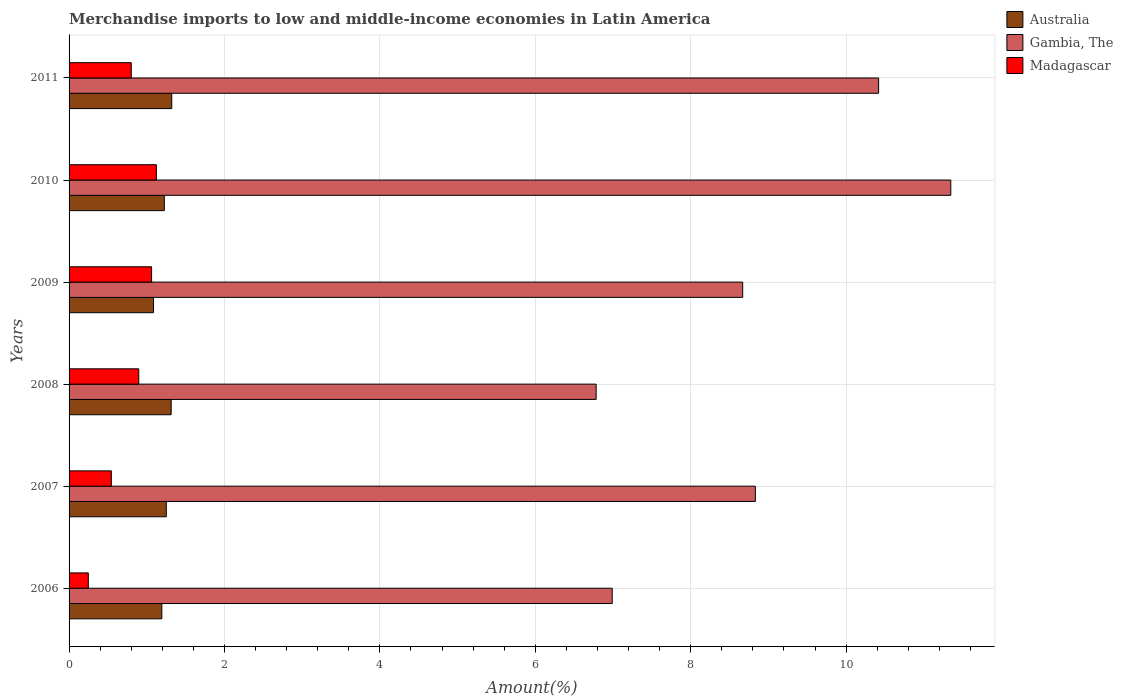How many different coloured bars are there?
Offer a terse response. 3. How many groups of bars are there?
Offer a very short reply. 6. Are the number of bars on each tick of the Y-axis equal?
Make the answer very short. Yes. How many bars are there on the 1st tick from the bottom?
Your answer should be very brief. 3. What is the label of the 5th group of bars from the top?
Provide a succinct answer. 2007. In how many cases, is the number of bars for a given year not equal to the number of legend labels?
Make the answer very short. 0. What is the percentage of amount earned from merchandise imports in Australia in 2007?
Provide a succinct answer. 1.25. Across all years, what is the maximum percentage of amount earned from merchandise imports in Madagascar?
Give a very brief answer. 1.12. Across all years, what is the minimum percentage of amount earned from merchandise imports in Gambia, The?
Make the answer very short. 6.78. What is the total percentage of amount earned from merchandise imports in Gambia, The in the graph?
Ensure brevity in your answer.  53.04. What is the difference between the percentage of amount earned from merchandise imports in Australia in 2007 and that in 2008?
Provide a succinct answer. -0.06. What is the difference between the percentage of amount earned from merchandise imports in Madagascar in 2006 and the percentage of amount earned from merchandise imports in Australia in 2008?
Your answer should be compact. -1.07. What is the average percentage of amount earned from merchandise imports in Gambia, The per year?
Make the answer very short. 8.84. In the year 2010, what is the difference between the percentage of amount earned from merchandise imports in Australia and percentage of amount earned from merchandise imports in Madagascar?
Offer a terse response. 0.1. In how many years, is the percentage of amount earned from merchandise imports in Australia greater than 5.2 %?
Your answer should be compact. 0. What is the ratio of the percentage of amount earned from merchandise imports in Madagascar in 2007 to that in 2008?
Ensure brevity in your answer.  0.61. Is the difference between the percentage of amount earned from merchandise imports in Australia in 2008 and 2010 greater than the difference between the percentage of amount earned from merchandise imports in Madagascar in 2008 and 2010?
Ensure brevity in your answer.  Yes. What is the difference between the highest and the second highest percentage of amount earned from merchandise imports in Madagascar?
Your response must be concise. 0.06. What is the difference between the highest and the lowest percentage of amount earned from merchandise imports in Madagascar?
Offer a very short reply. 0.88. In how many years, is the percentage of amount earned from merchandise imports in Madagascar greater than the average percentage of amount earned from merchandise imports in Madagascar taken over all years?
Your answer should be very brief. 4. What does the 2nd bar from the top in 2009 represents?
Your response must be concise. Gambia, The. What does the 3rd bar from the bottom in 2011 represents?
Make the answer very short. Madagascar. How many bars are there?
Offer a terse response. 18. Are all the bars in the graph horizontal?
Ensure brevity in your answer.  Yes. How many years are there in the graph?
Ensure brevity in your answer.  6. How many legend labels are there?
Make the answer very short. 3. What is the title of the graph?
Make the answer very short. Merchandise imports to low and middle-income economies in Latin America. Does "Bangladesh" appear as one of the legend labels in the graph?
Give a very brief answer. No. What is the label or title of the X-axis?
Give a very brief answer. Amount(%). What is the Amount(%) in Australia in 2006?
Offer a very short reply. 1.19. What is the Amount(%) in Gambia, The in 2006?
Give a very brief answer. 6.99. What is the Amount(%) in Madagascar in 2006?
Provide a succinct answer. 0.25. What is the Amount(%) in Australia in 2007?
Provide a succinct answer. 1.25. What is the Amount(%) of Gambia, The in 2007?
Offer a terse response. 8.83. What is the Amount(%) in Madagascar in 2007?
Keep it short and to the point. 0.54. What is the Amount(%) in Australia in 2008?
Your answer should be compact. 1.31. What is the Amount(%) in Gambia, The in 2008?
Your response must be concise. 6.78. What is the Amount(%) of Madagascar in 2008?
Offer a very short reply. 0.9. What is the Amount(%) of Australia in 2009?
Ensure brevity in your answer.  1.09. What is the Amount(%) in Gambia, The in 2009?
Make the answer very short. 8.67. What is the Amount(%) of Madagascar in 2009?
Offer a very short reply. 1.06. What is the Amount(%) of Australia in 2010?
Offer a very short reply. 1.23. What is the Amount(%) in Gambia, The in 2010?
Make the answer very short. 11.35. What is the Amount(%) in Madagascar in 2010?
Your response must be concise. 1.12. What is the Amount(%) in Australia in 2011?
Provide a short and direct response. 1.32. What is the Amount(%) of Gambia, The in 2011?
Your answer should be compact. 10.42. What is the Amount(%) in Madagascar in 2011?
Provide a short and direct response. 0.8. Across all years, what is the maximum Amount(%) of Australia?
Offer a terse response. 1.32. Across all years, what is the maximum Amount(%) of Gambia, The?
Offer a very short reply. 11.35. Across all years, what is the maximum Amount(%) in Madagascar?
Give a very brief answer. 1.12. Across all years, what is the minimum Amount(%) of Australia?
Provide a short and direct response. 1.09. Across all years, what is the minimum Amount(%) in Gambia, The?
Provide a succinct answer. 6.78. Across all years, what is the minimum Amount(%) of Madagascar?
Your answer should be compact. 0.25. What is the total Amount(%) of Australia in the graph?
Your answer should be very brief. 7.39. What is the total Amount(%) of Gambia, The in the graph?
Make the answer very short. 53.04. What is the total Amount(%) in Madagascar in the graph?
Your answer should be compact. 4.67. What is the difference between the Amount(%) in Australia in 2006 and that in 2007?
Your answer should be very brief. -0.06. What is the difference between the Amount(%) in Gambia, The in 2006 and that in 2007?
Your answer should be very brief. -1.84. What is the difference between the Amount(%) in Madagascar in 2006 and that in 2007?
Give a very brief answer. -0.3. What is the difference between the Amount(%) of Australia in 2006 and that in 2008?
Make the answer very short. -0.12. What is the difference between the Amount(%) of Gambia, The in 2006 and that in 2008?
Provide a short and direct response. 0.21. What is the difference between the Amount(%) of Madagascar in 2006 and that in 2008?
Offer a terse response. -0.65. What is the difference between the Amount(%) in Australia in 2006 and that in 2009?
Provide a succinct answer. 0.11. What is the difference between the Amount(%) of Gambia, The in 2006 and that in 2009?
Provide a succinct answer. -1.68. What is the difference between the Amount(%) of Madagascar in 2006 and that in 2009?
Your answer should be very brief. -0.81. What is the difference between the Amount(%) in Australia in 2006 and that in 2010?
Provide a succinct answer. -0.03. What is the difference between the Amount(%) of Gambia, The in 2006 and that in 2010?
Give a very brief answer. -4.36. What is the difference between the Amount(%) of Madagascar in 2006 and that in 2010?
Your answer should be very brief. -0.88. What is the difference between the Amount(%) in Australia in 2006 and that in 2011?
Ensure brevity in your answer.  -0.13. What is the difference between the Amount(%) in Gambia, The in 2006 and that in 2011?
Your response must be concise. -3.43. What is the difference between the Amount(%) in Madagascar in 2006 and that in 2011?
Offer a very short reply. -0.55. What is the difference between the Amount(%) of Australia in 2007 and that in 2008?
Your answer should be very brief. -0.06. What is the difference between the Amount(%) of Gambia, The in 2007 and that in 2008?
Provide a succinct answer. 2.05. What is the difference between the Amount(%) in Madagascar in 2007 and that in 2008?
Ensure brevity in your answer.  -0.35. What is the difference between the Amount(%) of Australia in 2007 and that in 2009?
Your response must be concise. 0.16. What is the difference between the Amount(%) of Gambia, The in 2007 and that in 2009?
Make the answer very short. 0.16. What is the difference between the Amount(%) of Madagascar in 2007 and that in 2009?
Offer a very short reply. -0.52. What is the difference between the Amount(%) of Australia in 2007 and that in 2010?
Make the answer very short. 0.03. What is the difference between the Amount(%) in Gambia, The in 2007 and that in 2010?
Offer a very short reply. -2.52. What is the difference between the Amount(%) in Madagascar in 2007 and that in 2010?
Keep it short and to the point. -0.58. What is the difference between the Amount(%) in Australia in 2007 and that in 2011?
Keep it short and to the point. -0.07. What is the difference between the Amount(%) of Gambia, The in 2007 and that in 2011?
Provide a succinct answer. -1.59. What is the difference between the Amount(%) in Madagascar in 2007 and that in 2011?
Your answer should be very brief. -0.26. What is the difference between the Amount(%) in Australia in 2008 and that in 2009?
Offer a very short reply. 0.23. What is the difference between the Amount(%) of Gambia, The in 2008 and that in 2009?
Offer a terse response. -1.89. What is the difference between the Amount(%) of Madagascar in 2008 and that in 2009?
Your answer should be very brief. -0.17. What is the difference between the Amount(%) of Australia in 2008 and that in 2010?
Keep it short and to the point. 0.09. What is the difference between the Amount(%) in Gambia, The in 2008 and that in 2010?
Offer a very short reply. -4.56. What is the difference between the Amount(%) in Madagascar in 2008 and that in 2010?
Your response must be concise. -0.23. What is the difference between the Amount(%) of Australia in 2008 and that in 2011?
Ensure brevity in your answer.  -0.01. What is the difference between the Amount(%) in Gambia, The in 2008 and that in 2011?
Provide a succinct answer. -3.63. What is the difference between the Amount(%) of Madagascar in 2008 and that in 2011?
Ensure brevity in your answer.  0.1. What is the difference between the Amount(%) of Australia in 2009 and that in 2010?
Ensure brevity in your answer.  -0.14. What is the difference between the Amount(%) of Gambia, The in 2009 and that in 2010?
Your response must be concise. -2.68. What is the difference between the Amount(%) of Madagascar in 2009 and that in 2010?
Your answer should be very brief. -0.06. What is the difference between the Amount(%) of Australia in 2009 and that in 2011?
Provide a short and direct response. -0.23. What is the difference between the Amount(%) of Gambia, The in 2009 and that in 2011?
Keep it short and to the point. -1.75. What is the difference between the Amount(%) in Madagascar in 2009 and that in 2011?
Offer a terse response. 0.26. What is the difference between the Amount(%) of Australia in 2010 and that in 2011?
Ensure brevity in your answer.  -0.1. What is the difference between the Amount(%) of Gambia, The in 2010 and that in 2011?
Make the answer very short. 0.93. What is the difference between the Amount(%) of Madagascar in 2010 and that in 2011?
Keep it short and to the point. 0.32. What is the difference between the Amount(%) of Australia in 2006 and the Amount(%) of Gambia, The in 2007?
Provide a short and direct response. -7.64. What is the difference between the Amount(%) in Australia in 2006 and the Amount(%) in Madagascar in 2007?
Offer a very short reply. 0.65. What is the difference between the Amount(%) in Gambia, The in 2006 and the Amount(%) in Madagascar in 2007?
Provide a short and direct response. 6.45. What is the difference between the Amount(%) in Australia in 2006 and the Amount(%) in Gambia, The in 2008?
Keep it short and to the point. -5.59. What is the difference between the Amount(%) of Australia in 2006 and the Amount(%) of Madagascar in 2008?
Provide a short and direct response. 0.3. What is the difference between the Amount(%) in Gambia, The in 2006 and the Amount(%) in Madagascar in 2008?
Provide a short and direct response. 6.09. What is the difference between the Amount(%) in Australia in 2006 and the Amount(%) in Gambia, The in 2009?
Offer a very short reply. -7.47. What is the difference between the Amount(%) in Australia in 2006 and the Amount(%) in Madagascar in 2009?
Offer a terse response. 0.13. What is the difference between the Amount(%) of Gambia, The in 2006 and the Amount(%) of Madagascar in 2009?
Your answer should be compact. 5.93. What is the difference between the Amount(%) in Australia in 2006 and the Amount(%) in Gambia, The in 2010?
Provide a short and direct response. -10.15. What is the difference between the Amount(%) of Australia in 2006 and the Amount(%) of Madagascar in 2010?
Offer a very short reply. 0.07. What is the difference between the Amount(%) in Gambia, The in 2006 and the Amount(%) in Madagascar in 2010?
Offer a terse response. 5.87. What is the difference between the Amount(%) of Australia in 2006 and the Amount(%) of Gambia, The in 2011?
Ensure brevity in your answer.  -9.22. What is the difference between the Amount(%) in Australia in 2006 and the Amount(%) in Madagascar in 2011?
Offer a very short reply. 0.39. What is the difference between the Amount(%) in Gambia, The in 2006 and the Amount(%) in Madagascar in 2011?
Your response must be concise. 6.19. What is the difference between the Amount(%) in Australia in 2007 and the Amount(%) in Gambia, The in 2008?
Make the answer very short. -5.53. What is the difference between the Amount(%) in Australia in 2007 and the Amount(%) in Madagascar in 2008?
Give a very brief answer. 0.35. What is the difference between the Amount(%) in Gambia, The in 2007 and the Amount(%) in Madagascar in 2008?
Ensure brevity in your answer.  7.93. What is the difference between the Amount(%) in Australia in 2007 and the Amount(%) in Gambia, The in 2009?
Ensure brevity in your answer.  -7.42. What is the difference between the Amount(%) in Australia in 2007 and the Amount(%) in Madagascar in 2009?
Make the answer very short. 0.19. What is the difference between the Amount(%) in Gambia, The in 2007 and the Amount(%) in Madagascar in 2009?
Provide a succinct answer. 7.77. What is the difference between the Amount(%) in Australia in 2007 and the Amount(%) in Gambia, The in 2010?
Offer a terse response. -10.1. What is the difference between the Amount(%) of Australia in 2007 and the Amount(%) of Madagascar in 2010?
Your response must be concise. 0.13. What is the difference between the Amount(%) in Gambia, The in 2007 and the Amount(%) in Madagascar in 2010?
Your response must be concise. 7.71. What is the difference between the Amount(%) in Australia in 2007 and the Amount(%) in Gambia, The in 2011?
Keep it short and to the point. -9.17. What is the difference between the Amount(%) of Australia in 2007 and the Amount(%) of Madagascar in 2011?
Provide a short and direct response. 0.45. What is the difference between the Amount(%) in Gambia, The in 2007 and the Amount(%) in Madagascar in 2011?
Provide a short and direct response. 8.03. What is the difference between the Amount(%) of Australia in 2008 and the Amount(%) of Gambia, The in 2009?
Ensure brevity in your answer.  -7.36. What is the difference between the Amount(%) in Australia in 2008 and the Amount(%) in Madagascar in 2009?
Provide a succinct answer. 0.25. What is the difference between the Amount(%) of Gambia, The in 2008 and the Amount(%) of Madagascar in 2009?
Keep it short and to the point. 5.72. What is the difference between the Amount(%) of Australia in 2008 and the Amount(%) of Gambia, The in 2010?
Your answer should be very brief. -10.03. What is the difference between the Amount(%) of Australia in 2008 and the Amount(%) of Madagascar in 2010?
Make the answer very short. 0.19. What is the difference between the Amount(%) in Gambia, The in 2008 and the Amount(%) in Madagascar in 2010?
Keep it short and to the point. 5.66. What is the difference between the Amount(%) of Australia in 2008 and the Amount(%) of Gambia, The in 2011?
Your answer should be compact. -9.1. What is the difference between the Amount(%) of Australia in 2008 and the Amount(%) of Madagascar in 2011?
Keep it short and to the point. 0.51. What is the difference between the Amount(%) in Gambia, The in 2008 and the Amount(%) in Madagascar in 2011?
Keep it short and to the point. 5.98. What is the difference between the Amount(%) of Australia in 2009 and the Amount(%) of Gambia, The in 2010?
Give a very brief answer. -10.26. What is the difference between the Amount(%) in Australia in 2009 and the Amount(%) in Madagascar in 2010?
Offer a very short reply. -0.04. What is the difference between the Amount(%) in Gambia, The in 2009 and the Amount(%) in Madagascar in 2010?
Provide a succinct answer. 7.54. What is the difference between the Amount(%) in Australia in 2009 and the Amount(%) in Gambia, The in 2011?
Ensure brevity in your answer.  -9.33. What is the difference between the Amount(%) of Australia in 2009 and the Amount(%) of Madagascar in 2011?
Give a very brief answer. 0.29. What is the difference between the Amount(%) of Gambia, The in 2009 and the Amount(%) of Madagascar in 2011?
Provide a succinct answer. 7.87. What is the difference between the Amount(%) of Australia in 2010 and the Amount(%) of Gambia, The in 2011?
Offer a terse response. -9.19. What is the difference between the Amount(%) of Australia in 2010 and the Amount(%) of Madagascar in 2011?
Give a very brief answer. 0.43. What is the difference between the Amount(%) in Gambia, The in 2010 and the Amount(%) in Madagascar in 2011?
Make the answer very short. 10.55. What is the average Amount(%) in Australia per year?
Keep it short and to the point. 1.23. What is the average Amount(%) of Gambia, The per year?
Offer a terse response. 8.84. What is the average Amount(%) of Madagascar per year?
Your answer should be very brief. 0.78. In the year 2006, what is the difference between the Amount(%) in Australia and Amount(%) in Gambia, The?
Provide a succinct answer. -5.8. In the year 2006, what is the difference between the Amount(%) of Australia and Amount(%) of Madagascar?
Offer a very short reply. 0.95. In the year 2006, what is the difference between the Amount(%) of Gambia, The and Amount(%) of Madagascar?
Keep it short and to the point. 6.74. In the year 2007, what is the difference between the Amount(%) of Australia and Amount(%) of Gambia, The?
Your answer should be very brief. -7.58. In the year 2007, what is the difference between the Amount(%) of Australia and Amount(%) of Madagascar?
Your answer should be very brief. 0.71. In the year 2007, what is the difference between the Amount(%) in Gambia, The and Amount(%) in Madagascar?
Your answer should be very brief. 8.29. In the year 2008, what is the difference between the Amount(%) in Australia and Amount(%) in Gambia, The?
Provide a succinct answer. -5.47. In the year 2008, what is the difference between the Amount(%) in Australia and Amount(%) in Madagascar?
Keep it short and to the point. 0.42. In the year 2008, what is the difference between the Amount(%) in Gambia, The and Amount(%) in Madagascar?
Keep it short and to the point. 5.89. In the year 2009, what is the difference between the Amount(%) of Australia and Amount(%) of Gambia, The?
Make the answer very short. -7.58. In the year 2009, what is the difference between the Amount(%) of Australia and Amount(%) of Madagascar?
Provide a succinct answer. 0.03. In the year 2009, what is the difference between the Amount(%) of Gambia, The and Amount(%) of Madagascar?
Your answer should be compact. 7.61. In the year 2010, what is the difference between the Amount(%) of Australia and Amount(%) of Gambia, The?
Offer a terse response. -10.12. In the year 2010, what is the difference between the Amount(%) in Australia and Amount(%) in Madagascar?
Offer a terse response. 0.1. In the year 2010, what is the difference between the Amount(%) of Gambia, The and Amount(%) of Madagascar?
Your answer should be very brief. 10.22. In the year 2011, what is the difference between the Amount(%) in Australia and Amount(%) in Gambia, The?
Give a very brief answer. -9.1. In the year 2011, what is the difference between the Amount(%) in Australia and Amount(%) in Madagascar?
Provide a succinct answer. 0.52. In the year 2011, what is the difference between the Amount(%) of Gambia, The and Amount(%) of Madagascar?
Offer a very short reply. 9.62. What is the ratio of the Amount(%) of Australia in 2006 to that in 2007?
Give a very brief answer. 0.95. What is the ratio of the Amount(%) of Gambia, The in 2006 to that in 2007?
Give a very brief answer. 0.79. What is the ratio of the Amount(%) in Madagascar in 2006 to that in 2007?
Offer a very short reply. 0.46. What is the ratio of the Amount(%) of Australia in 2006 to that in 2008?
Offer a terse response. 0.91. What is the ratio of the Amount(%) of Gambia, The in 2006 to that in 2008?
Your answer should be very brief. 1.03. What is the ratio of the Amount(%) of Madagascar in 2006 to that in 2008?
Your response must be concise. 0.28. What is the ratio of the Amount(%) in Australia in 2006 to that in 2009?
Provide a succinct answer. 1.1. What is the ratio of the Amount(%) of Gambia, The in 2006 to that in 2009?
Provide a short and direct response. 0.81. What is the ratio of the Amount(%) in Madagascar in 2006 to that in 2009?
Keep it short and to the point. 0.23. What is the ratio of the Amount(%) in Australia in 2006 to that in 2010?
Your answer should be compact. 0.97. What is the ratio of the Amount(%) of Gambia, The in 2006 to that in 2010?
Provide a short and direct response. 0.62. What is the ratio of the Amount(%) of Madagascar in 2006 to that in 2010?
Ensure brevity in your answer.  0.22. What is the ratio of the Amount(%) in Australia in 2006 to that in 2011?
Provide a succinct answer. 0.9. What is the ratio of the Amount(%) in Gambia, The in 2006 to that in 2011?
Offer a terse response. 0.67. What is the ratio of the Amount(%) in Madagascar in 2006 to that in 2011?
Provide a short and direct response. 0.31. What is the ratio of the Amount(%) in Australia in 2007 to that in 2008?
Your answer should be compact. 0.95. What is the ratio of the Amount(%) of Gambia, The in 2007 to that in 2008?
Give a very brief answer. 1.3. What is the ratio of the Amount(%) of Madagascar in 2007 to that in 2008?
Make the answer very short. 0.61. What is the ratio of the Amount(%) in Australia in 2007 to that in 2009?
Make the answer very short. 1.15. What is the ratio of the Amount(%) of Gambia, The in 2007 to that in 2009?
Make the answer very short. 1.02. What is the ratio of the Amount(%) of Madagascar in 2007 to that in 2009?
Offer a very short reply. 0.51. What is the ratio of the Amount(%) of Australia in 2007 to that in 2010?
Give a very brief answer. 1.02. What is the ratio of the Amount(%) in Gambia, The in 2007 to that in 2010?
Offer a very short reply. 0.78. What is the ratio of the Amount(%) in Madagascar in 2007 to that in 2010?
Offer a terse response. 0.48. What is the ratio of the Amount(%) of Australia in 2007 to that in 2011?
Your response must be concise. 0.95. What is the ratio of the Amount(%) in Gambia, The in 2007 to that in 2011?
Offer a terse response. 0.85. What is the ratio of the Amount(%) in Madagascar in 2007 to that in 2011?
Provide a short and direct response. 0.68. What is the ratio of the Amount(%) of Australia in 2008 to that in 2009?
Make the answer very short. 1.21. What is the ratio of the Amount(%) of Gambia, The in 2008 to that in 2009?
Your answer should be compact. 0.78. What is the ratio of the Amount(%) in Madagascar in 2008 to that in 2009?
Your answer should be very brief. 0.84. What is the ratio of the Amount(%) in Australia in 2008 to that in 2010?
Provide a succinct answer. 1.07. What is the ratio of the Amount(%) in Gambia, The in 2008 to that in 2010?
Ensure brevity in your answer.  0.6. What is the ratio of the Amount(%) of Madagascar in 2008 to that in 2010?
Keep it short and to the point. 0.8. What is the ratio of the Amount(%) of Gambia, The in 2008 to that in 2011?
Ensure brevity in your answer.  0.65. What is the ratio of the Amount(%) in Madagascar in 2008 to that in 2011?
Provide a short and direct response. 1.12. What is the ratio of the Amount(%) in Australia in 2009 to that in 2010?
Your answer should be very brief. 0.89. What is the ratio of the Amount(%) in Gambia, The in 2009 to that in 2010?
Offer a terse response. 0.76. What is the ratio of the Amount(%) in Madagascar in 2009 to that in 2010?
Offer a very short reply. 0.94. What is the ratio of the Amount(%) of Australia in 2009 to that in 2011?
Your response must be concise. 0.82. What is the ratio of the Amount(%) of Gambia, The in 2009 to that in 2011?
Keep it short and to the point. 0.83. What is the ratio of the Amount(%) of Madagascar in 2009 to that in 2011?
Offer a very short reply. 1.33. What is the ratio of the Amount(%) of Australia in 2010 to that in 2011?
Your response must be concise. 0.93. What is the ratio of the Amount(%) in Gambia, The in 2010 to that in 2011?
Offer a very short reply. 1.09. What is the ratio of the Amount(%) in Madagascar in 2010 to that in 2011?
Keep it short and to the point. 1.4. What is the difference between the highest and the second highest Amount(%) in Australia?
Keep it short and to the point. 0.01. What is the difference between the highest and the second highest Amount(%) of Gambia, The?
Make the answer very short. 0.93. What is the difference between the highest and the second highest Amount(%) in Madagascar?
Provide a succinct answer. 0.06. What is the difference between the highest and the lowest Amount(%) in Australia?
Your answer should be very brief. 0.23. What is the difference between the highest and the lowest Amount(%) in Gambia, The?
Give a very brief answer. 4.56. What is the difference between the highest and the lowest Amount(%) of Madagascar?
Provide a short and direct response. 0.88. 